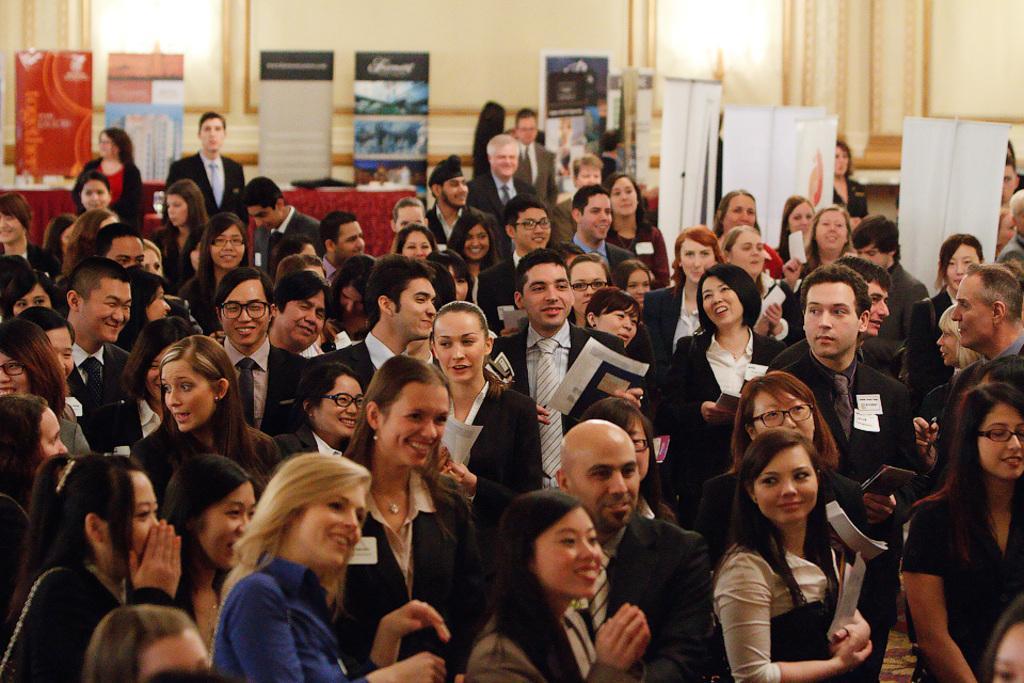How would you summarize this image in a sentence or two? In the picture we can see many people are standing there and smiling. The background of the image is blurred, where we can see many boards, lights, table on which few objects are kept and the wall. 